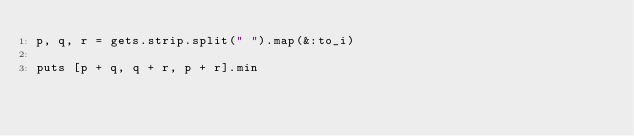Convert code to text. <code><loc_0><loc_0><loc_500><loc_500><_Ruby_>p, q, r = gets.strip.split(" ").map(&:to_i)

puts [p + q, q + r, p + r].min
</code> 